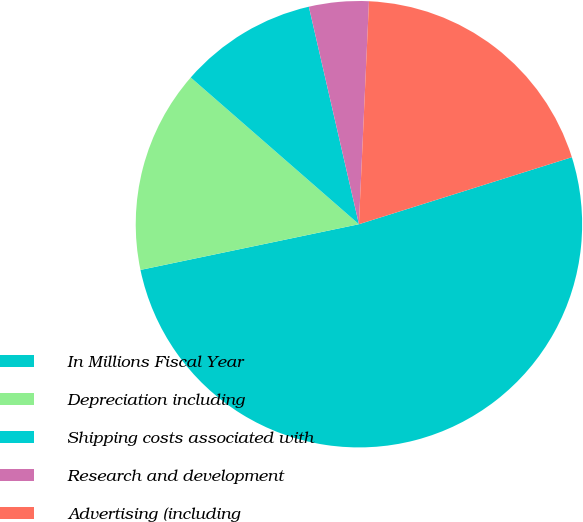Convert chart to OTSL. <chart><loc_0><loc_0><loc_500><loc_500><pie_chart><fcel>In Millions Fiscal Year<fcel>Depreciation including<fcel>Shipping costs associated with<fcel>Research and development<fcel>Advertising (including<nl><fcel>51.57%<fcel>14.7%<fcel>9.98%<fcel>4.32%<fcel>19.43%<nl></chart> 